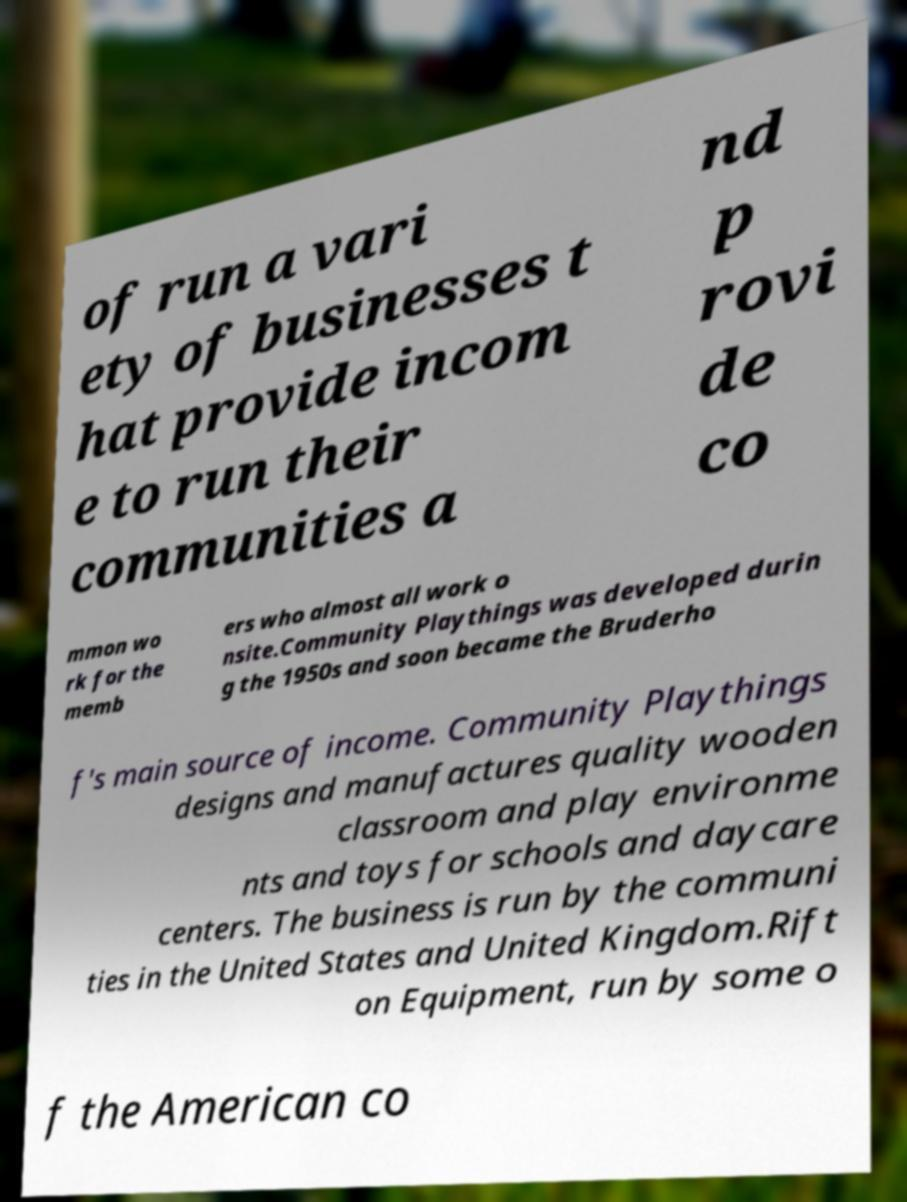Can you read and provide the text displayed in the image?This photo seems to have some interesting text. Can you extract and type it out for me? of run a vari ety of businesses t hat provide incom e to run their communities a nd p rovi de co mmon wo rk for the memb ers who almost all work o nsite.Community Playthings was developed durin g the 1950s and soon became the Bruderho f's main source of income. Community Playthings designs and manufactures quality wooden classroom and play environme nts and toys for schools and daycare centers. The business is run by the communi ties in the United States and United Kingdom.Rift on Equipment, run by some o f the American co 